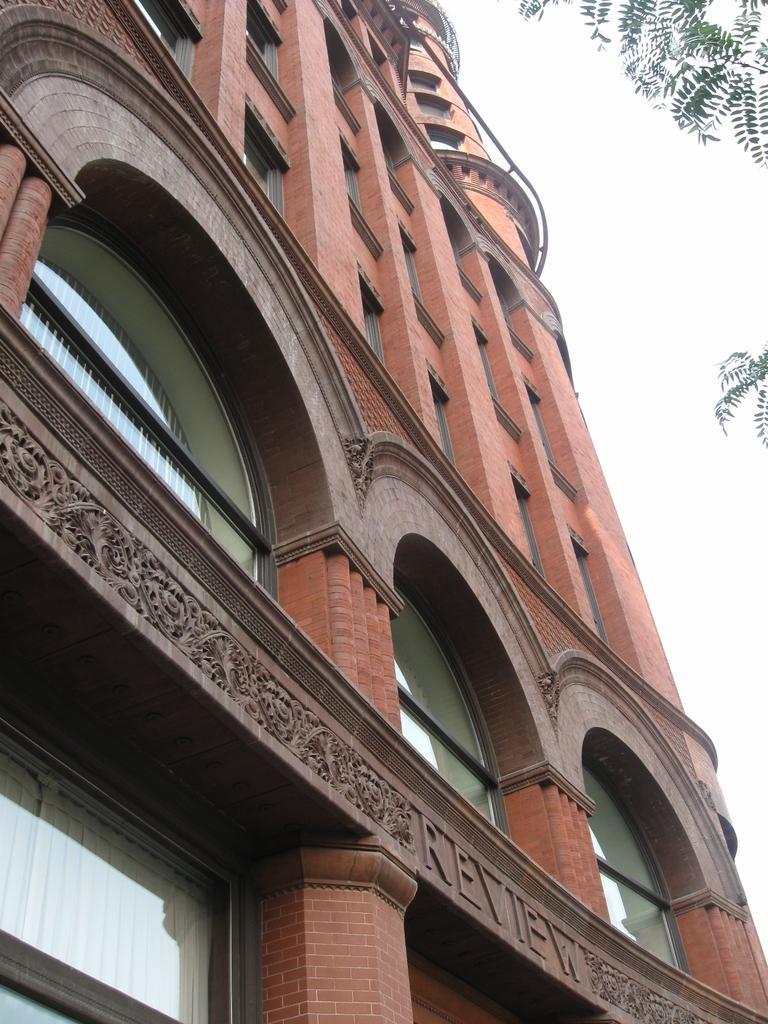Describe this image in one or two sentences. In this image I see a building which is of light brown and dark brown in color and I see a word written over here and I see the designs over here and I see the window glasses. In the background I see the sky and I see green leaves on the stems. 